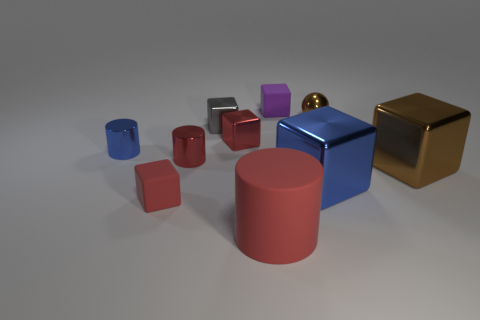There is a rubber object that is behind the large rubber object and in front of the tiny brown metal sphere; how big is it?
Offer a terse response. Small. How many spheres are either tiny purple objects or big brown shiny objects?
Offer a very short reply. 0. What is the color of the ball that is the same size as the purple object?
Keep it short and to the point. Brown. Is there anything else that has the same shape as the small gray metal object?
Make the answer very short. Yes. There is another matte object that is the same shape as the purple object; what is its color?
Make the answer very short. Red. How many things are either red matte things or red things that are in front of the blue shiny cylinder?
Ensure brevity in your answer.  3. Is the number of big blue objects that are behind the large red cylinder less than the number of red things?
Make the answer very short. Yes. How big is the matte object that is behind the red cylinder that is behind the thing that is right of the small shiny sphere?
Make the answer very short. Small. There is a cube that is in front of the brown metal block and on the left side of the large blue shiny thing; what is its color?
Your answer should be compact. Red. What number of large matte cylinders are there?
Keep it short and to the point. 1. 